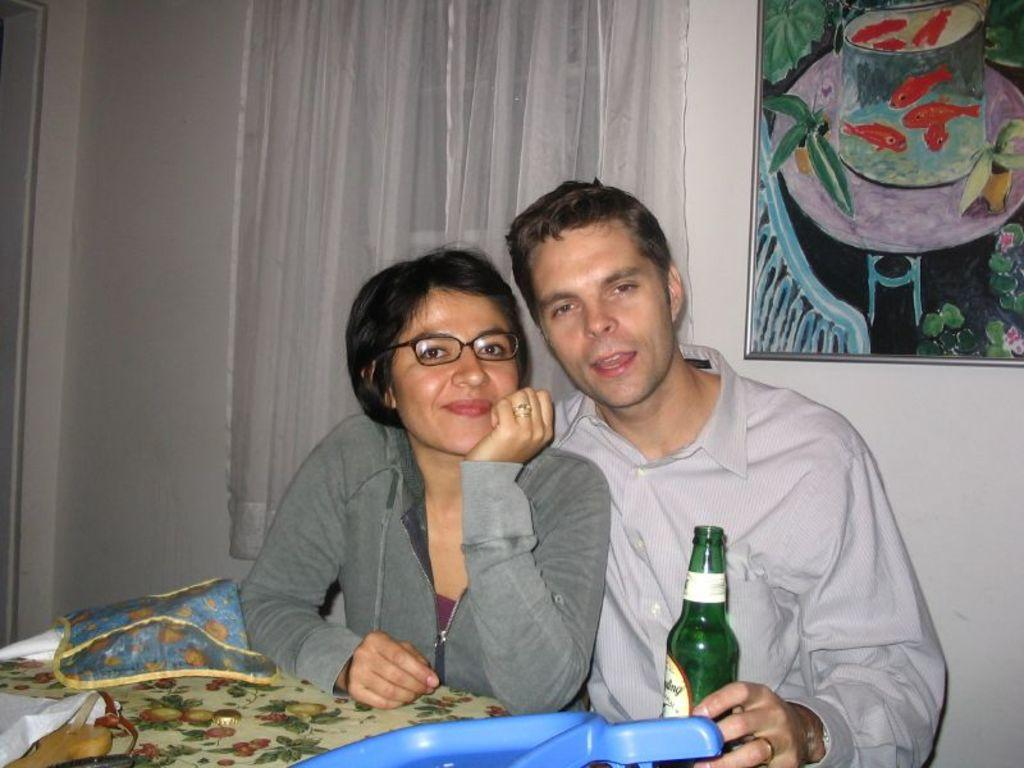How many people are present in the image? There is a man and a woman present in the image. What is the woman doing in the image? The woman is sitting on a chair. What objects can be seen on the table in the image? There is a bottle and a bag on the table. What is visible in the background of the image? There is a curtain in the background of the image. What is hanging on the wall in the image? There is a frame on the wall. Can you tell me how many rivers are visible in the image? There are no rivers visible in the image. What type of meat is being served on the table in the image? There is no meat present in the image. 